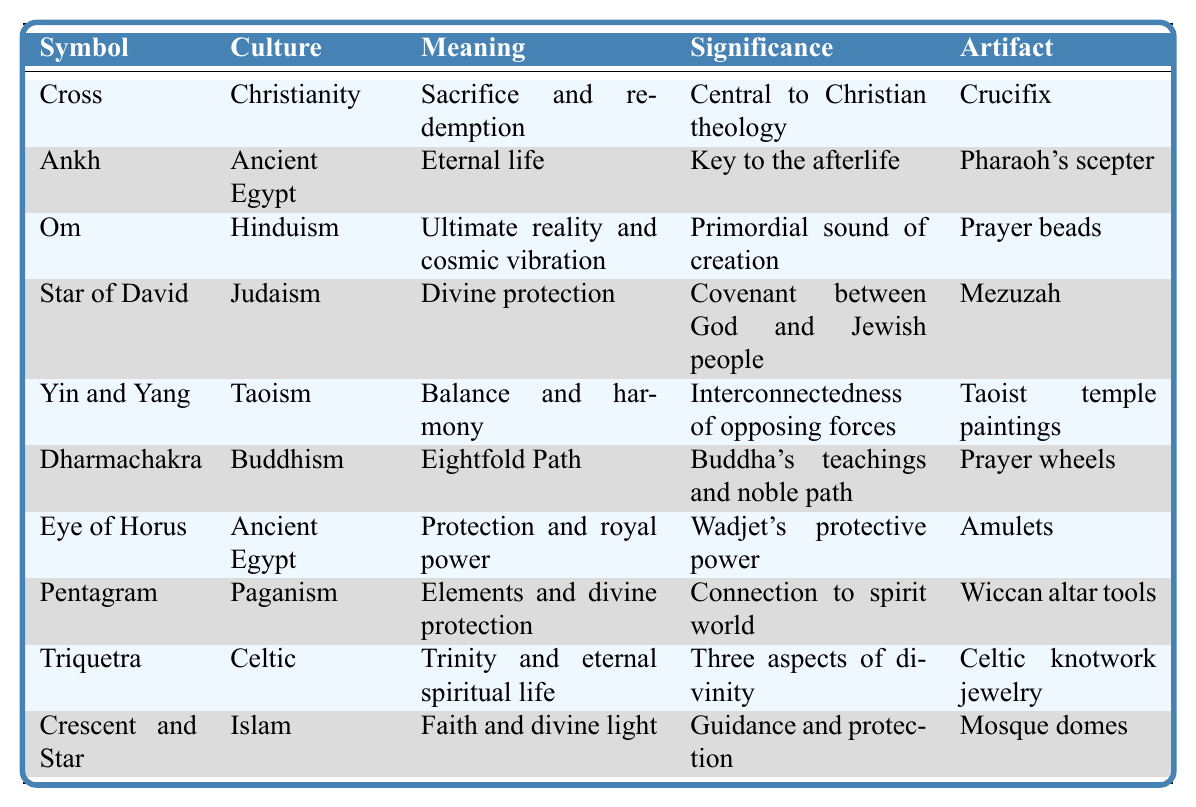What is the meaning associated with the Cross symbol? The meaning associated with the Cross symbol is "Sacrifice and redemption," as indicated in the table.
Answer: Sacrifice and redemption Which culture does the Ankh symbol belong to? The Ankh symbol belongs to Ancient Egypt, as shown in the culture column of the table.
Answer: Ancient Egypt What artifact is related to the Star of David? The artifact related to the Star of David is the Mezuzah, as listed in the table.
Answer: Mezuzah Does the Eye of Horus symbolize protection? Yes, according to the table, the Eye of Horus symbolizes "Protection and royal power."
Answer: Yes What are the two symbols associated with Ancient Egypt? The two symbols associated with Ancient Egypt are the Ankh and the Eye of Horus, which are both listed under that culture in the table.
Answer: Ankh and Eye of Horus Which symbol has the meaning of "Faith and divine light"? The symbol that has the meaning of "Faith and divine light" is the Crescent and Star, as noted in the meanings section of the table.
Answer: Crescent and Star How many symbols represent concepts from Eastern religions? There are four symbols that represent concepts from Eastern religions: Om (Hinduism), Yin and Yang (Taoism), Dharmachakra (Buddhism), and the Eye of Horus (Ancient Egypt, often associated with spiritual concepts). Summing these up gives a total of 4.
Answer: 4 What is the significance of the Yin and Yang symbol? The significance of the Yin and Yang symbol is "Interconnectedness of opposing forces," as per the significance in the table.
Answer: Interconnectedness of opposing forces Which artifact represents the teachings of Buddhism? The artifact that represents the teachings of Buddhism is the Prayer wheels, corroborated by the table's association with the Dharmachakra symbol.
Answer: Prayer wheels Is there a symbol that represents both protection and spiritual connection? Yes, the Pentagram symbolizes "Elements and divine protection" and reflects a connection to the spirit world, according to the table.
Answer: Yes 